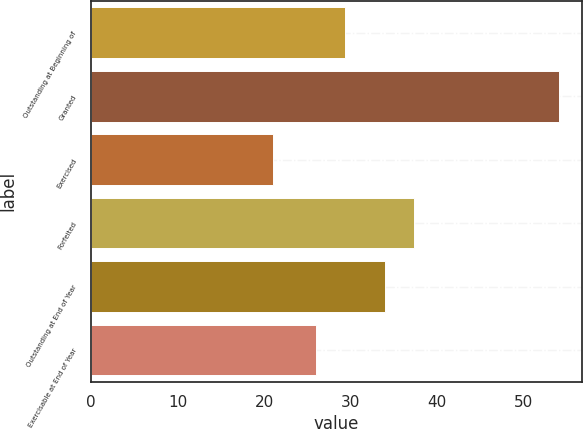<chart> <loc_0><loc_0><loc_500><loc_500><bar_chart><fcel>Outstanding at Beginning of<fcel>Granted<fcel>Exercised<fcel>Forfeited<fcel>Outstanding at End of Year<fcel>Exercisable at End of Year<nl><fcel>29.3<fcel>54<fcel>21<fcel>37.3<fcel>34<fcel>26<nl></chart> 